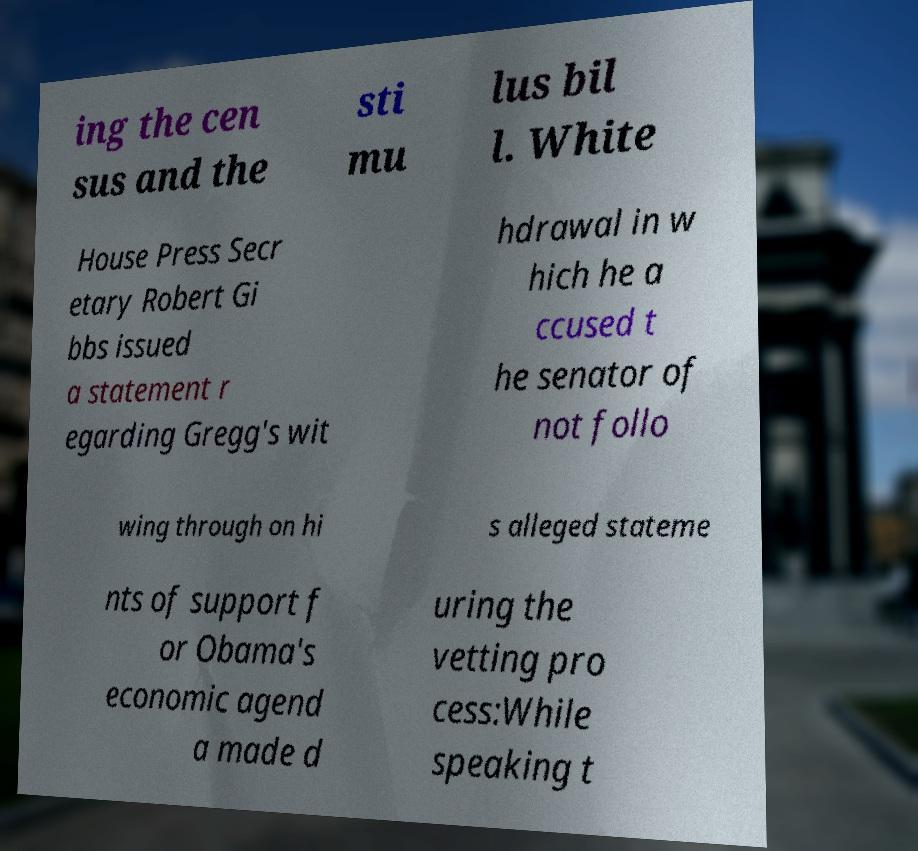Could you extract and type out the text from this image? ing the cen sus and the sti mu lus bil l. White House Press Secr etary Robert Gi bbs issued a statement r egarding Gregg's wit hdrawal in w hich he a ccused t he senator of not follo wing through on hi s alleged stateme nts of support f or Obama's economic agend a made d uring the vetting pro cess:While speaking t 